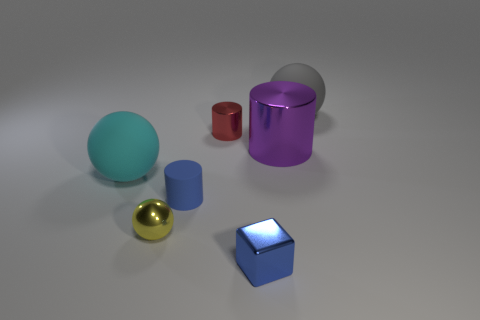What is the material of the small yellow sphere?
Provide a succinct answer. Metal. The blue shiny object has what shape?
Offer a very short reply. Cube. How many things are the same color as the cube?
Keep it short and to the point. 1. The tiny ball that is in front of the small cylinder that is behind the tiny blue object behind the yellow thing is made of what material?
Keep it short and to the point. Metal. What number of red things are either large cylinders or small shiny objects?
Offer a terse response. 1. What size is the matte object behind the big rubber sphere that is in front of the rubber sphere that is behind the large purple metal cylinder?
Provide a short and direct response. Large. What is the size of the gray thing that is the same shape as the large cyan matte thing?
Provide a succinct answer. Large. How many small things are either gray cylinders or metallic objects?
Keep it short and to the point. 3. Do the large sphere right of the tiny yellow metal thing and the object on the left side of the yellow metal object have the same material?
Your answer should be compact. Yes. There is a small thing right of the small red thing; what is it made of?
Offer a very short reply. Metal. 